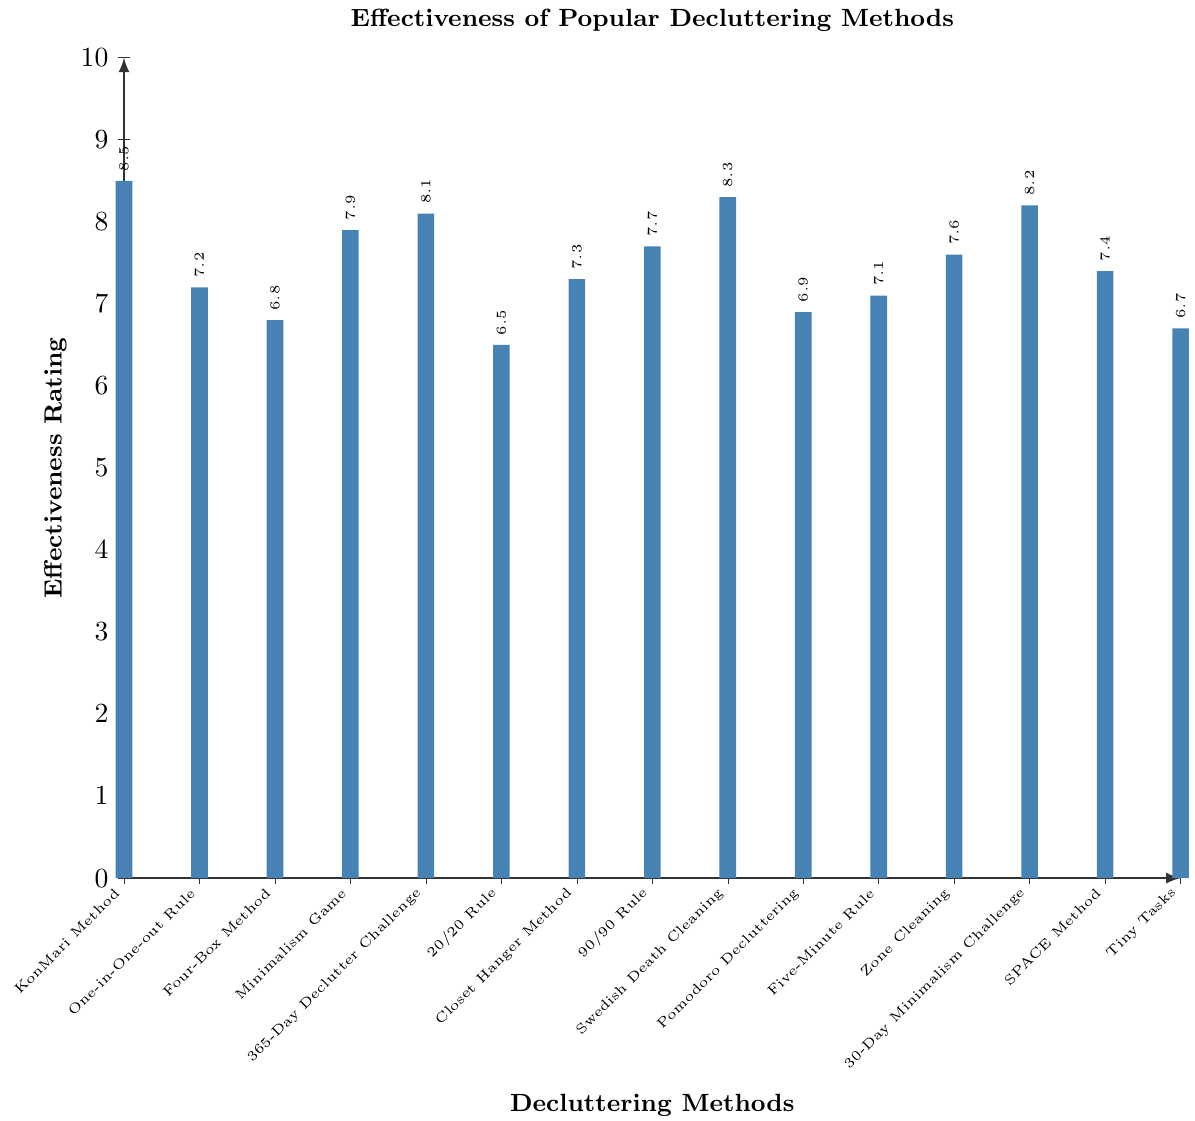What's the most effective decluttering method? Look at the bar with the highest effectiveness rating. The highest bar corresponds to the KonMari Method with a rating of 8.5.
Answer: KonMari Method Which method has a higher effectiveness rating: the 365-Day Declutter Challenge or the 30-Day Minimalism Challenge? Compare the heights of the bars for the 365-Day Declutter Challenge and the 30-Day Minimalism Challenge. The 30-Day Minimalism Challenge has a rating of 8.2, which is slightly less than the 8.1 rating of the 365-Day Declutter Challenge.
Answer: 365-Day Declutter Challenge What is the average effectiveness rating of the 'One-in-One-out Rule' and 'Closet Hanger Method'? The effectiveness rating of the 'One-in-One-out Rule' is 7.2 and the 'Closet Hanger Method' is 7.3. The average is calculated as (7.2 + 7.3) / 2 = 7.25.
Answer: 7.25 How many methods have an effectiveness rating above 8? Count the number of bars that exceed the effectiveness rating of 8. Those methods are: KonMari Method (8.5), 365-Day Declutter Challenge (8.1), Swedish Death Cleaning (8.3), and 30-Day Minimalism Challenge (8.2). There are four such methods.
Answer: 4 Is 'Pomodoro Decluttering' more effective than the 'Four-Box Method'? Compare the effectiveness ratings of 'Pomodoro Decluttering' and 'Four-Box Method'. 'Pomodoro Decluttering' has a rating of 6.9, while 'Four-Box Method' has a rating of 6.8. Hence, 'Pomodoro Decluttering' is slightly more effective.
Answer: Yes Which decluttering method has the lowest effectiveness rating? Identify the bar with the lowest height. The '20/20 Rule' has the lowest effectiveness rating of 6.5.
Answer: 20/20 Rule What is the total effectiveness rating of all the methods combined? Sum the effectiveness ratings of all the methods: 8.5 + 7.2 + 6.8 + 7.9 + 8.1 + 6.5 + 7.3 + 7.7 + 8.3 + 6.9 + 7.1 + 7.6 + 8.2 + 7.4 + 6.7 = 106.2.
Answer: 106.2 